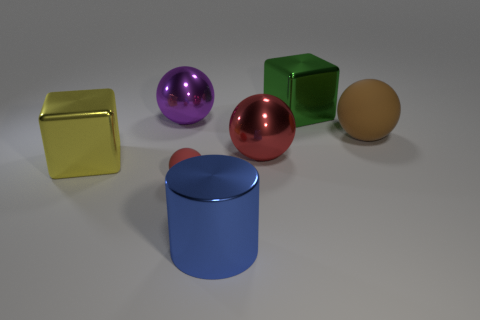Is there any other thing that is the same size as the red rubber object?
Your answer should be compact. No. What material is the big ball to the right of the large red metal sphere?
Your answer should be very brief. Rubber. The metallic thing that is the same color as the tiny ball is what size?
Keep it short and to the point. Large. Does the big ball that is left of the small red matte thing have the same color as the matte thing to the left of the blue metallic cylinder?
Offer a terse response. No. What number of objects are large cyan matte cubes or small spheres?
Provide a short and direct response. 1. How many other things are the same shape as the blue thing?
Make the answer very short. 0. Does the cube to the left of the tiny ball have the same material as the sphere left of the tiny red object?
Provide a short and direct response. Yes. There is a metal object that is both left of the metal cylinder and to the right of the yellow metal thing; what is its shape?
Your answer should be very brief. Sphere. There is a sphere that is both to the right of the purple sphere and left of the red metallic object; what is its material?
Your answer should be very brief. Rubber. The large red object that is made of the same material as the green object is what shape?
Keep it short and to the point. Sphere. 